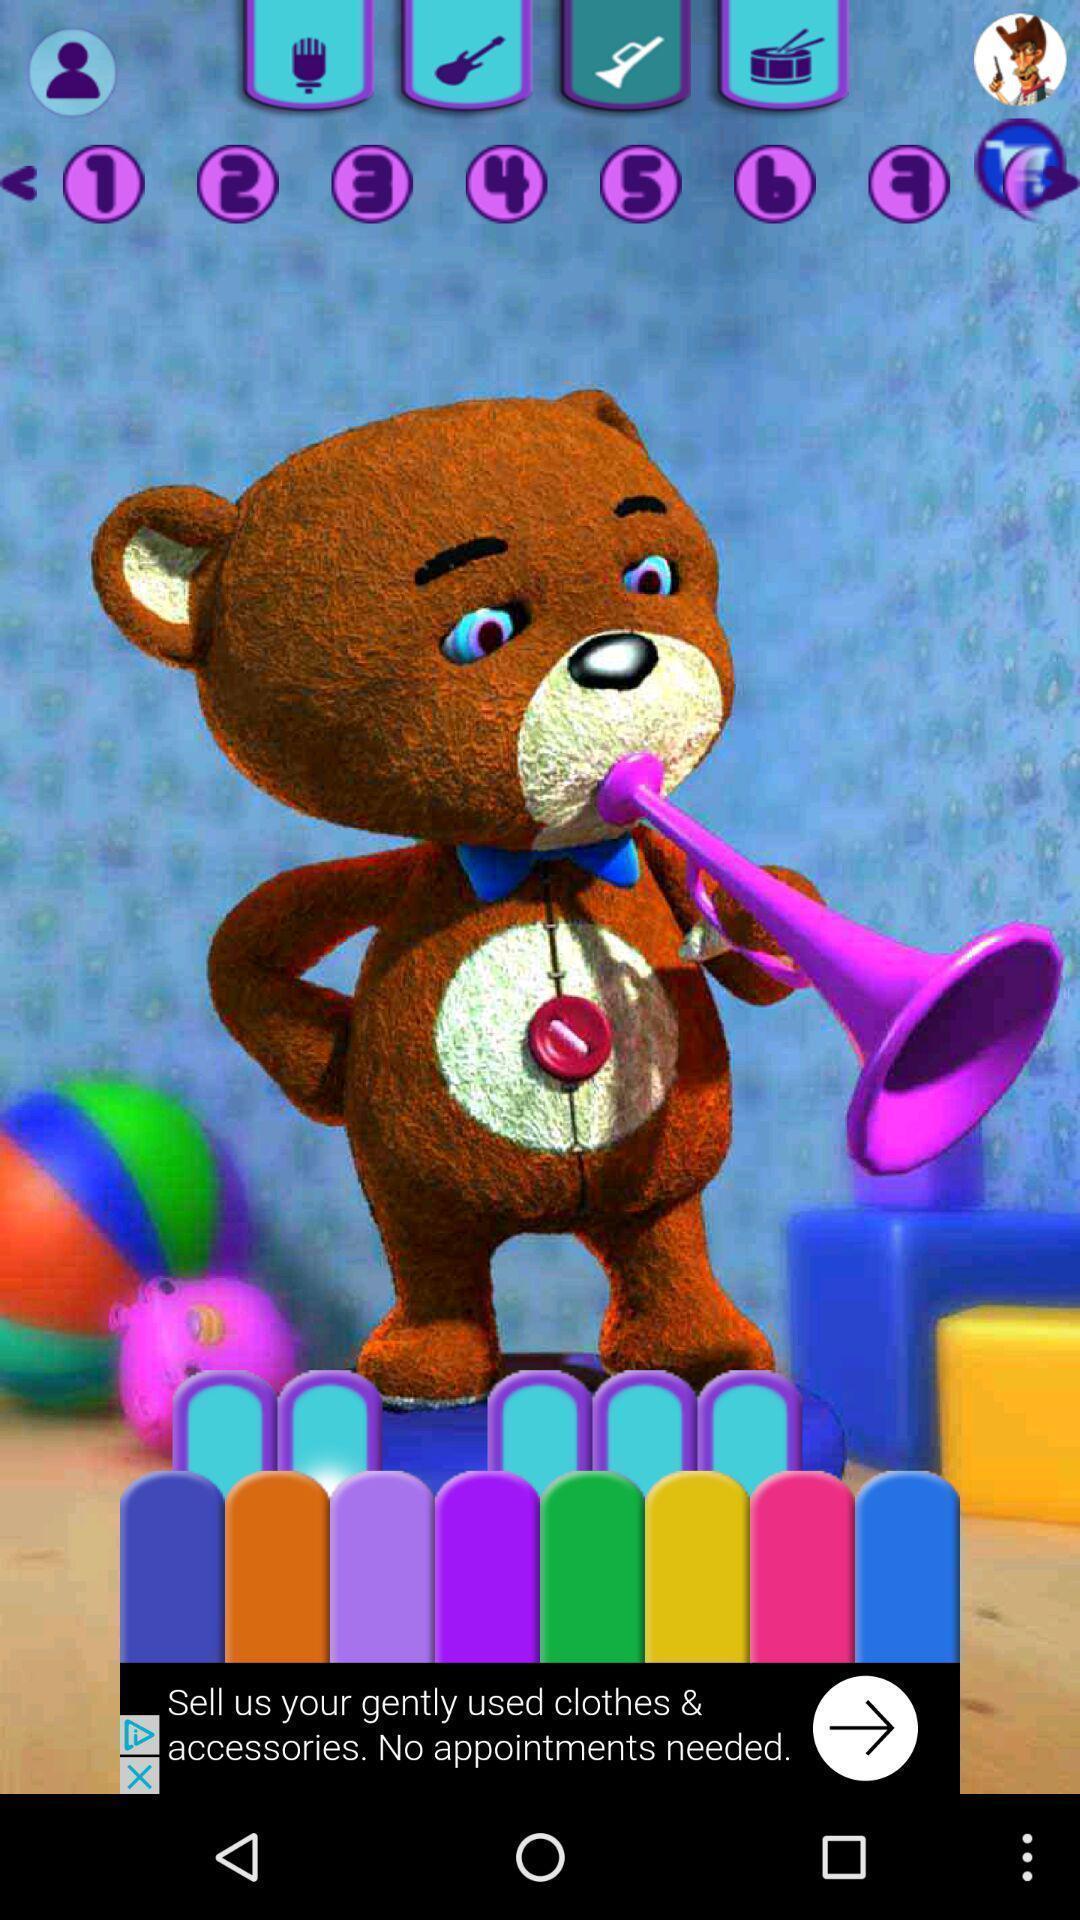Tell me what you see in this picture. Page of a music app. 